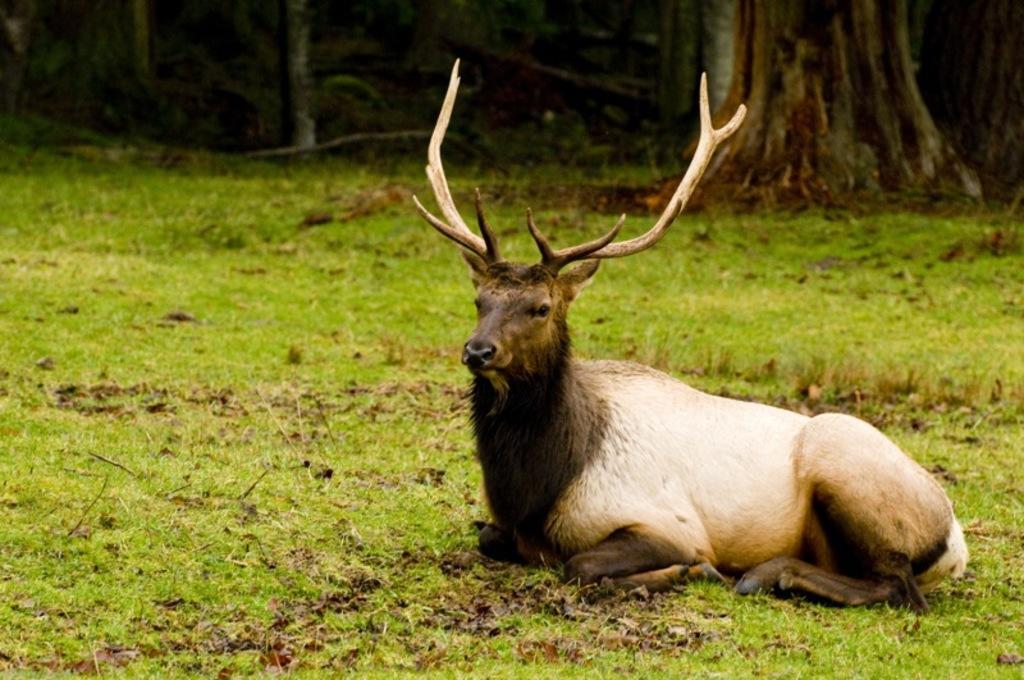Can you describe this image briefly? In this image we can see a deer on the ground. In the background, we can see a group of trees. 